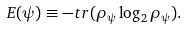<formula> <loc_0><loc_0><loc_500><loc_500>E ( \psi ) \equiv - t r ( \rho _ { \psi } \log _ { 2 } \rho _ { \psi } ) .</formula> 